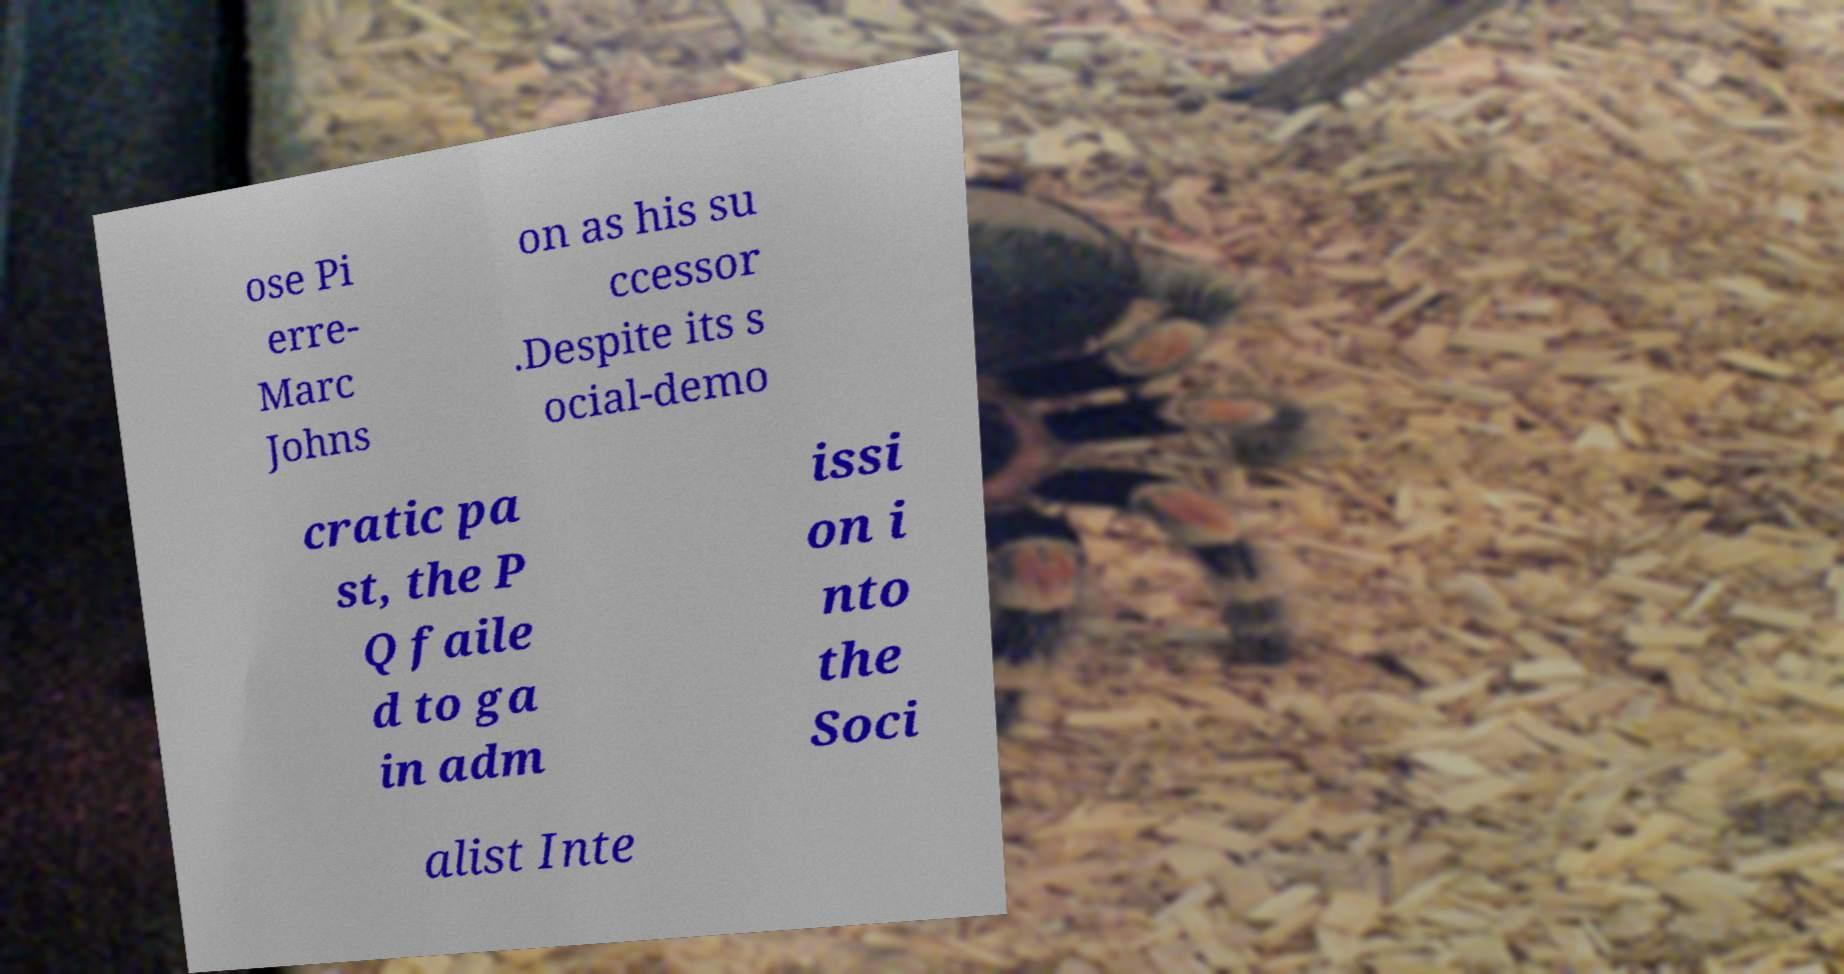What messages or text are displayed in this image? I need them in a readable, typed format. ose Pi erre- Marc Johns on as his su ccessor .Despite its s ocial-demo cratic pa st, the P Q faile d to ga in adm issi on i nto the Soci alist Inte 